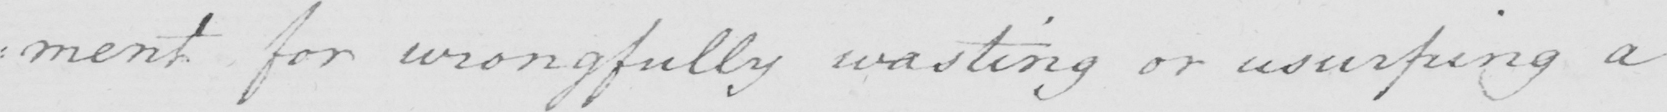What is written in this line of handwriting? : ment for wrongfully wasting or usurping a 